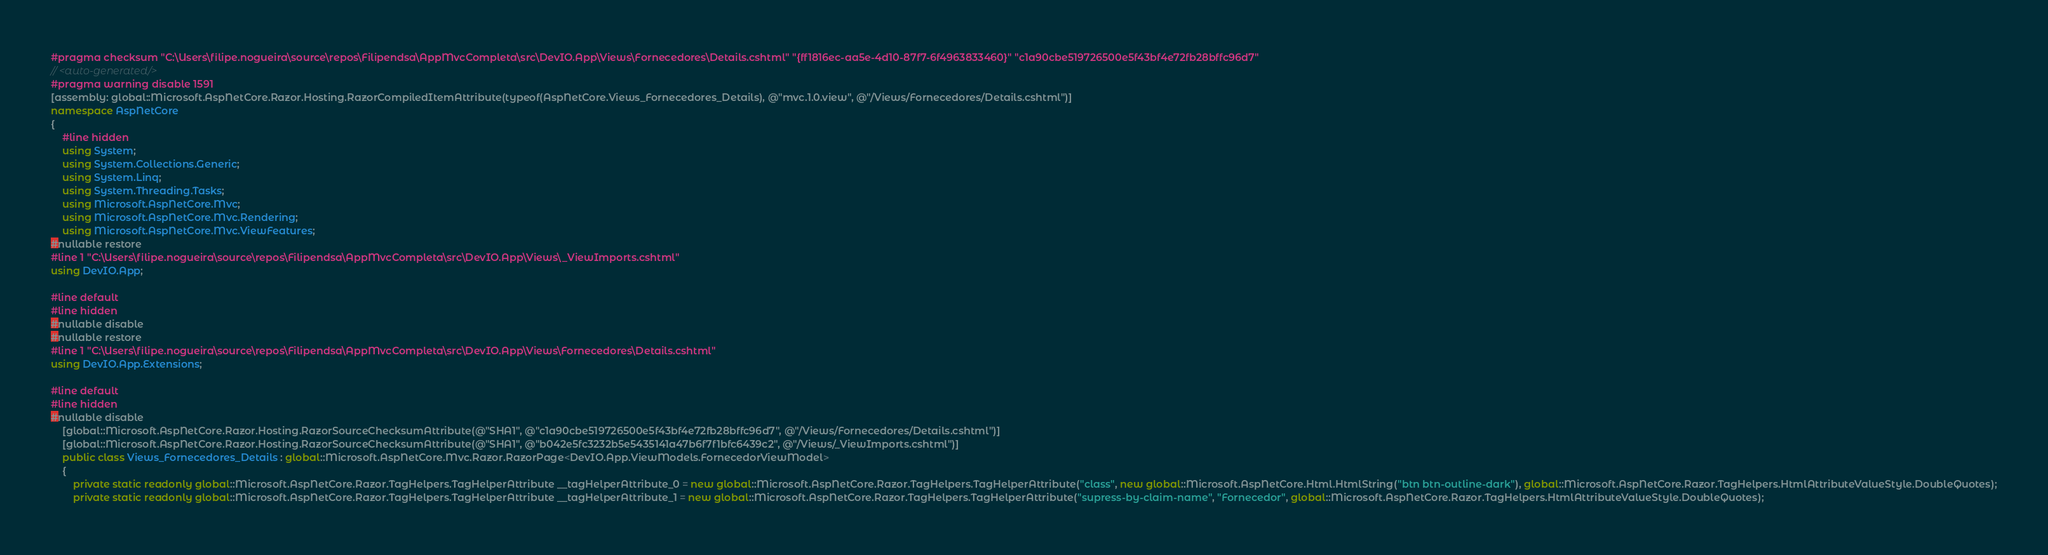Convert code to text. <code><loc_0><loc_0><loc_500><loc_500><_C#_>#pragma checksum "C:\Users\filipe.nogueira\source\repos\Filipendsa\AppMvcCompleta\src\DevIO.App\Views\Fornecedores\Details.cshtml" "{ff1816ec-aa5e-4d10-87f7-6f4963833460}" "c1a90cbe519726500e5f43bf4e72fb28bffc96d7"
// <auto-generated/>
#pragma warning disable 1591
[assembly: global::Microsoft.AspNetCore.Razor.Hosting.RazorCompiledItemAttribute(typeof(AspNetCore.Views_Fornecedores_Details), @"mvc.1.0.view", @"/Views/Fornecedores/Details.cshtml")]
namespace AspNetCore
{
    #line hidden
    using System;
    using System.Collections.Generic;
    using System.Linq;
    using System.Threading.Tasks;
    using Microsoft.AspNetCore.Mvc;
    using Microsoft.AspNetCore.Mvc.Rendering;
    using Microsoft.AspNetCore.Mvc.ViewFeatures;
#nullable restore
#line 1 "C:\Users\filipe.nogueira\source\repos\Filipendsa\AppMvcCompleta\src\DevIO.App\Views\_ViewImports.cshtml"
using DevIO.App;

#line default
#line hidden
#nullable disable
#nullable restore
#line 1 "C:\Users\filipe.nogueira\source\repos\Filipendsa\AppMvcCompleta\src\DevIO.App\Views\Fornecedores\Details.cshtml"
using DevIO.App.Extensions;

#line default
#line hidden
#nullable disable
    [global::Microsoft.AspNetCore.Razor.Hosting.RazorSourceChecksumAttribute(@"SHA1", @"c1a90cbe519726500e5f43bf4e72fb28bffc96d7", @"/Views/Fornecedores/Details.cshtml")]
    [global::Microsoft.AspNetCore.Razor.Hosting.RazorSourceChecksumAttribute(@"SHA1", @"b042e5fc3232b5e5435141a47b6f7f1bfc6439c2", @"/Views/_ViewImports.cshtml")]
    public class Views_Fornecedores_Details : global::Microsoft.AspNetCore.Mvc.Razor.RazorPage<DevIO.App.ViewModels.FornecedorViewModel>
    {
        private static readonly global::Microsoft.AspNetCore.Razor.TagHelpers.TagHelperAttribute __tagHelperAttribute_0 = new global::Microsoft.AspNetCore.Razor.TagHelpers.TagHelperAttribute("class", new global::Microsoft.AspNetCore.Html.HtmlString("btn btn-outline-dark"), global::Microsoft.AspNetCore.Razor.TagHelpers.HtmlAttributeValueStyle.DoubleQuotes);
        private static readonly global::Microsoft.AspNetCore.Razor.TagHelpers.TagHelperAttribute __tagHelperAttribute_1 = new global::Microsoft.AspNetCore.Razor.TagHelpers.TagHelperAttribute("supress-by-claim-name", "Fornecedor", global::Microsoft.AspNetCore.Razor.TagHelpers.HtmlAttributeValueStyle.DoubleQuotes);</code> 